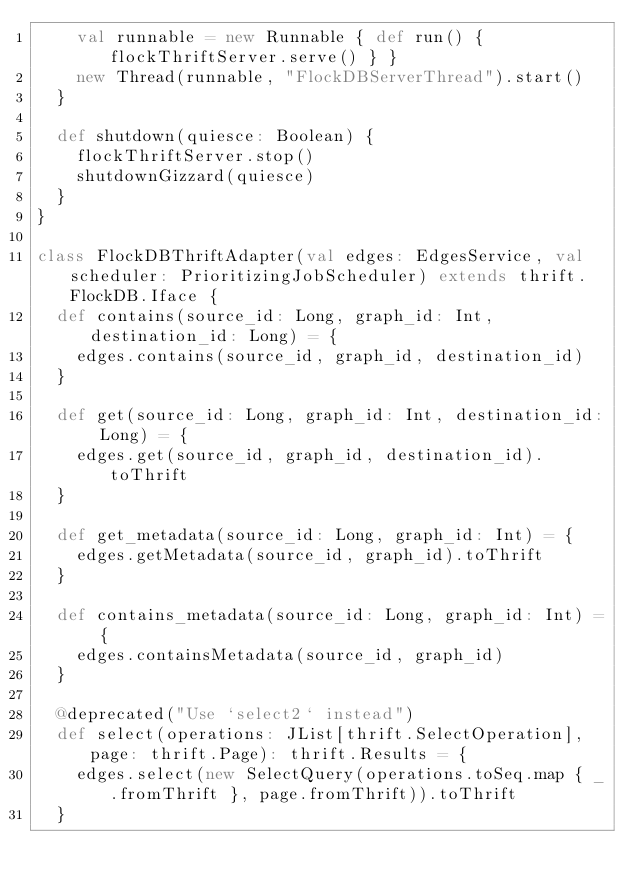Convert code to text. <code><loc_0><loc_0><loc_500><loc_500><_Scala_>    val runnable = new Runnable { def run() { flockThriftServer.serve() } }
    new Thread(runnable, "FlockDBServerThread").start()
  }

  def shutdown(quiesce: Boolean) {
    flockThriftServer.stop()
    shutdownGizzard(quiesce)
  }
}

class FlockDBThriftAdapter(val edges: EdgesService, val scheduler: PrioritizingJobScheduler) extends thrift.FlockDB.Iface {
  def contains(source_id: Long, graph_id: Int, destination_id: Long) = {
    edges.contains(source_id, graph_id, destination_id)
  }

  def get(source_id: Long, graph_id: Int, destination_id: Long) = {
    edges.get(source_id, graph_id, destination_id).toThrift
  }

  def get_metadata(source_id: Long, graph_id: Int) = {
    edges.getMetadata(source_id, graph_id).toThrift
  }

  def contains_metadata(source_id: Long, graph_id: Int) = {
    edges.containsMetadata(source_id, graph_id)
  }

  @deprecated("Use `select2` instead")
  def select(operations: JList[thrift.SelectOperation], page: thrift.Page): thrift.Results = {
    edges.select(new SelectQuery(operations.toSeq.map { _.fromThrift }, page.fromThrift)).toThrift
  }
</code> 